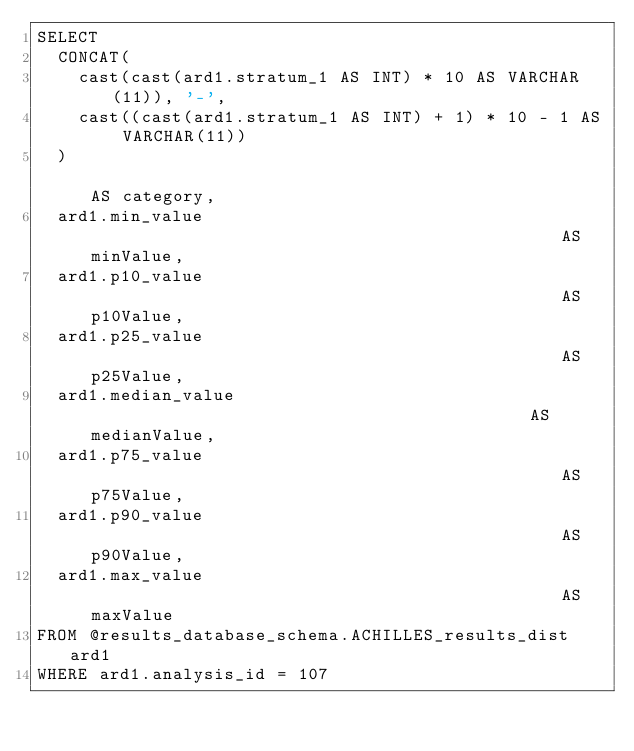<code> <loc_0><loc_0><loc_500><loc_500><_SQL_>SELECT
  CONCAT(
    cast(cast(ard1.stratum_1 AS INT) * 10 AS VARCHAR(11)), '-',
    cast((cast(ard1.stratum_1 AS INT) + 1) * 10 - 1 AS VARCHAR(11))
  )                                                           AS category,
  ard1.min_value                                              AS minValue,
  ard1.p10_value                                              AS p10Value,
  ard1.p25_value                                              AS p25Value,
  ard1.median_value                                           AS medianValue,
  ard1.p75_value                                              AS p75Value,
  ard1.p90_value                                              AS p90Value,
  ard1.max_value                                              AS maxValue
FROM @results_database_schema.ACHILLES_results_dist ard1
WHERE ard1.analysis_id = 107
</code> 